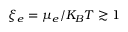Convert formula to latex. <formula><loc_0><loc_0><loc_500><loc_500>\xi _ { e } = \mu _ { e } / K _ { B } T \gtrsim 1</formula> 